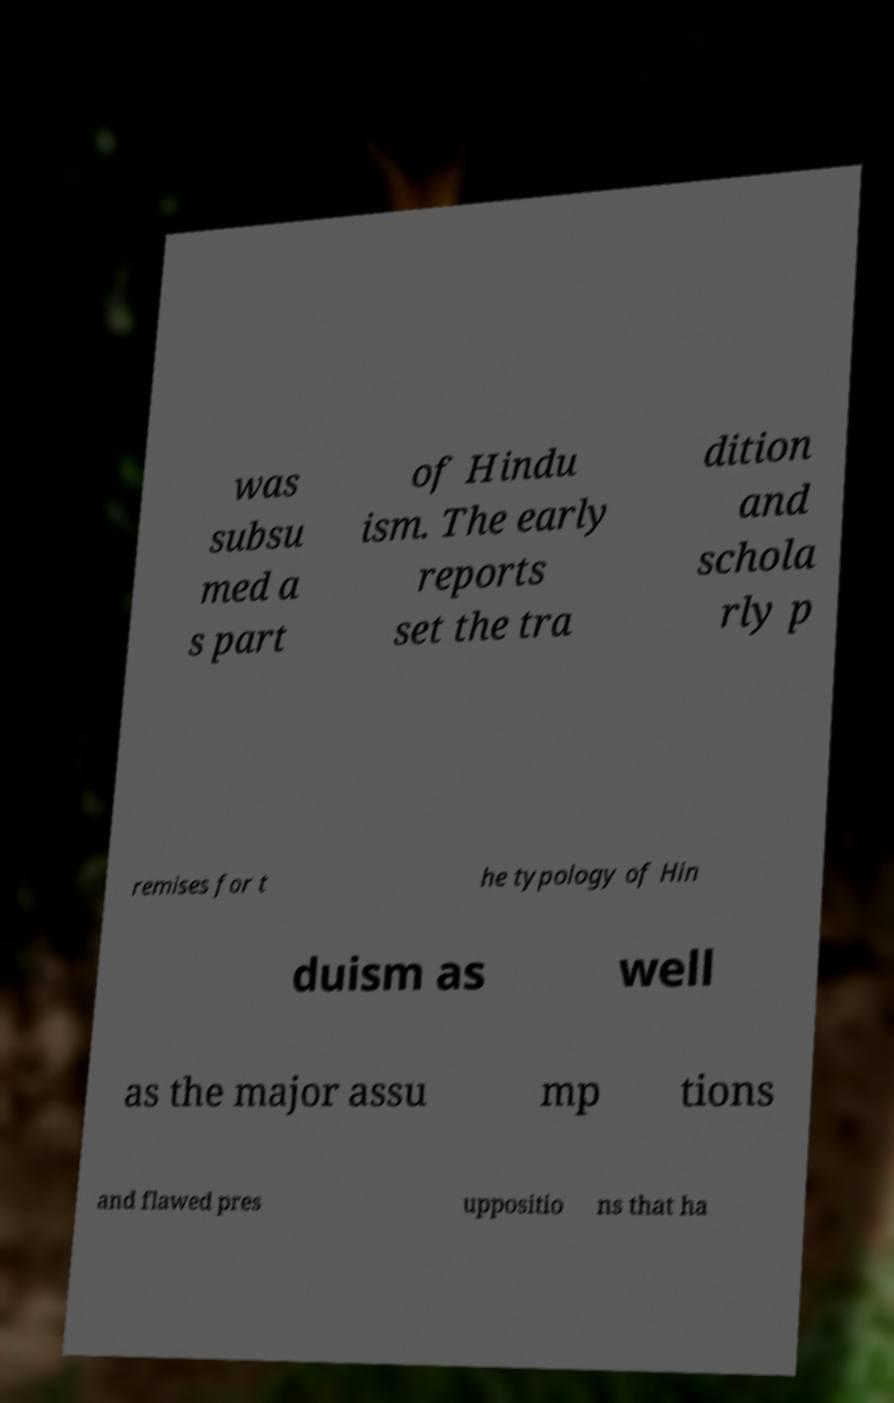What messages or text are displayed in this image? I need them in a readable, typed format. was subsu med a s part of Hindu ism. The early reports set the tra dition and schola rly p remises for t he typology of Hin duism as well as the major assu mp tions and flawed pres uppositio ns that ha 